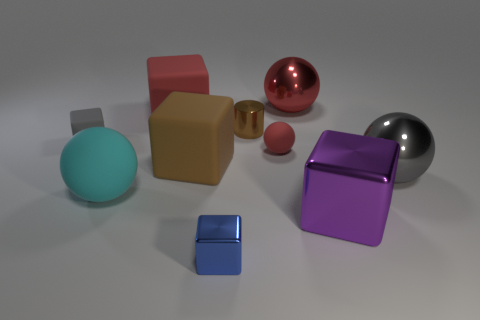Subtract 1 blocks. How many blocks are left? 4 Subtract all gray rubber blocks. How many blocks are left? 4 Subtract all blue blocks. How many blocks are left? 4 Subtract all cyan blocks. Subtract all yellow spheres. How many blocks are left? 5 Subtract all balls. How many objects are left? 6 Add 3 tiny blue objects. How many tiny blue objects exist? 4 Subtract 0 purple cylinders. How many objects are left? 10 Subtract all tiny brown matte balls. Subtract all red spheres. How many objects are left? 8 Add 6 small balls. How many small balls are left? 7 